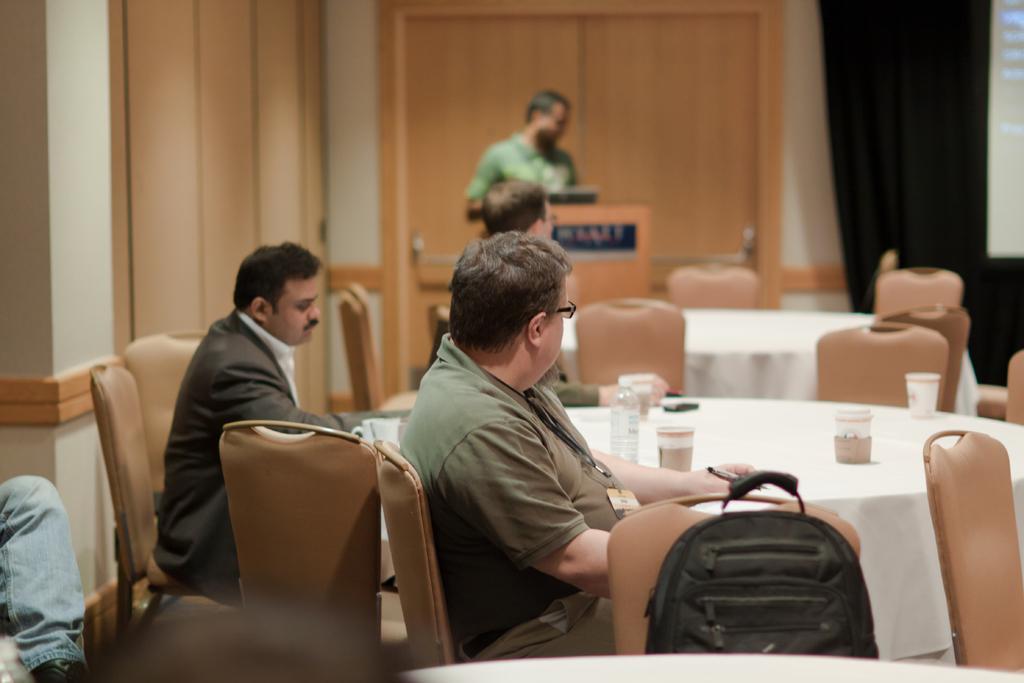Describe this image in one or two sentences. In this picture there are a group of people sitting, one of them is standing and they have a table in front of them and is also bag kept on the chair 